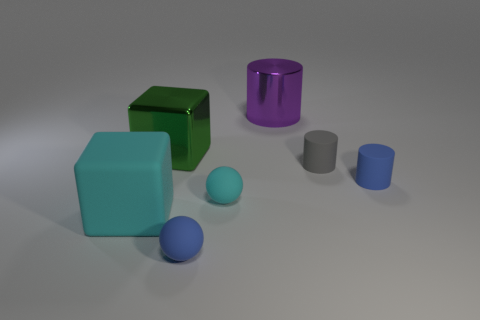Add 1 large matte blocks. How many objects exist? 8 Subtract all cubes. How many objects are left? 5 Add 5 purple metal cylinders. How many purple metal cylinders are left? 6 Add 7 small gray rubber cylinders. How many small gray rubber cylinders exist? 8 Subtract 0 blue blocks. How many objects are left? 7 Subtract all tiny red rubber blocks. Subtract all small cyan spheres. How many objects are left? 6 